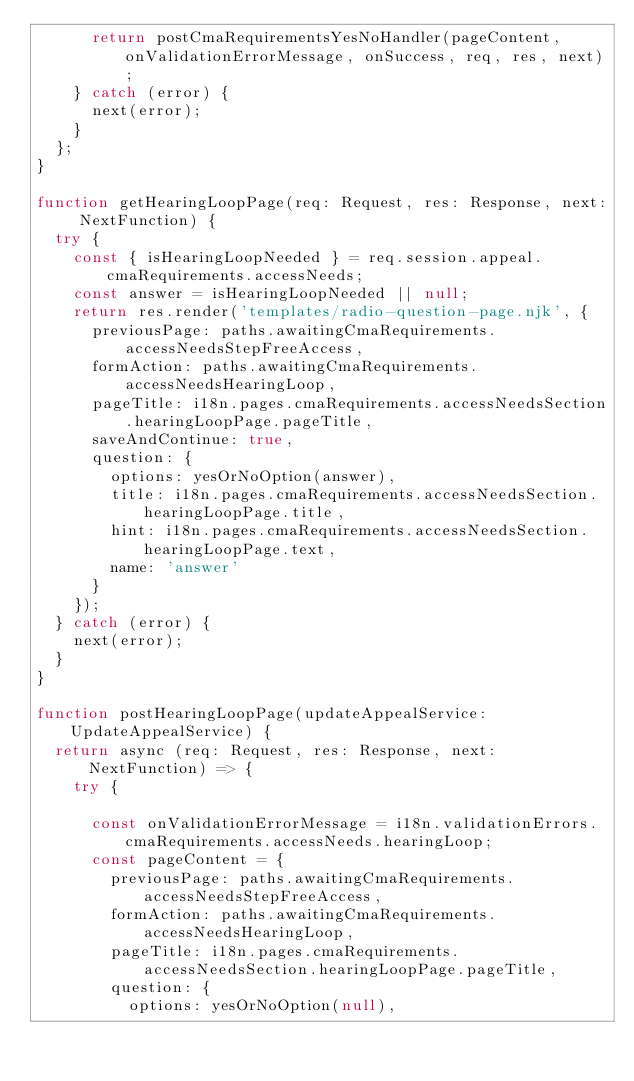<code> <loc_0><loc_0><loc_500><loc_500><_TypeScript_>      return postCmaRequirementsYesNoHandler(pageContent, onValidationErrorMessage, onSuccess, req, res, next);
    } catch (error) {
      next(error);
    }
  };
}

function getHearingLoopPage(req: Request, res: Response, next: NextFunction) {
  try {
    const { isHearingLoopNeeded } = req.session.appeal.cmaRequirements.accessNeeds;
    const answer = isHearingLoopNeeded || null;
    return res.render('templates/radio-question-page.njk', {
      previousPage: paths.awaitingCmaRequirements.accessNeedsStepFreeAccess,
      formAction: paths.awaitingCmaRequirements.accessNeedsHearingLoop,
      pageTitle: i18n.pages.cmaRequirements.accessNeedsSection.hearingLoopPage.pageTitle,
      saveAndContinue: true,
      question: {
        options: yesOrNoOption(answer),
        title: i18n.pages.cmaRequirements.accessNeedsSection.hearingLoopPage.title,
        hint: i18n.pages.cmaRequirements.accessNeedsSection.hearingLoopPage.text,
        name: 'answer'
      }
    });
  } catch (error) {
    next(error);
  }
}

function postHearingLoopPage(updateAppealService: UpdateAppealService) {
  return async (req: Request, res: Response, next: NextFunction) => {
    try {

      const onValidationErrorMessage = i18n.validationErrors.cmaRequirements.accessNeeds.hearingLoop;
      const pageContent = {
        previousPage: paths.awaitingCmaRequirements.accessNeedsStepFreeAccess,
        formAction: paths.awaitingCmaRequirements.accessNeedsHearingLoop,
        pageTitle: i18n.pages.cmaRequirements.accessNeedsSection.hearingLoopPage.pageTitle,
        question: {
          options: yesOrNoOption(null),</code> 